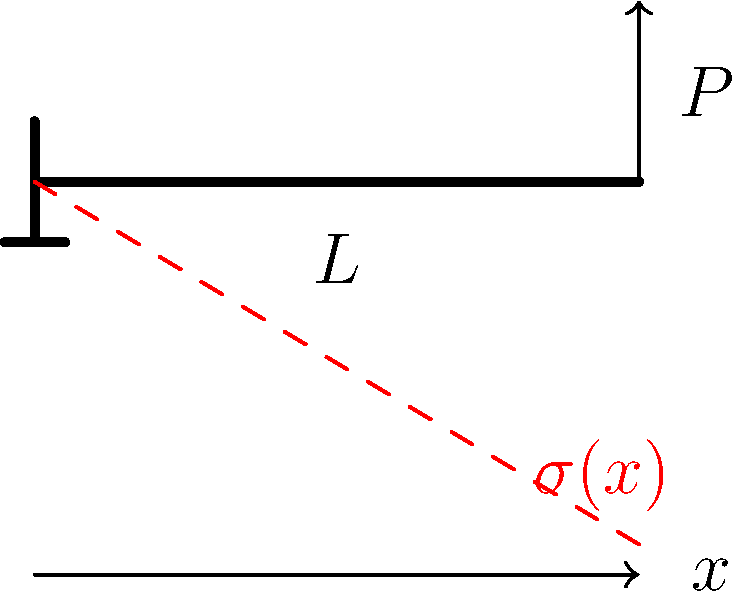Consider a cantilevered beam of length $L$ with a point load $P$ applied at its free end. Given that the stress distribution $\sigma(x)$ along the beam varies linearly, what is the mathematical expression for the bending stress $\sigma(x)$ at any point $x$ along the beam in terms of $P$, $L$, the moment of inertia $I$, and the distance $y$ from the neutral axis? To determine the stress distribution in the cantilevered beam, we'll follow these steps:

1) The bending moment $M(x)$ at any point $x$ along the beam is given by:
   $$M(x) = P(L-x)$$

2) The general equation for bending stress is:
   $$\sigma = \frac{My}{I}$$
   where $M$ is the bending moment, $y$ is the distance from the neutral axis, and $I$ is the moment of inertia.

3) Substituting the expression for $M(x)$ into the bending stress equation:
   $$\sigma(x) = \frac{P(L-x)y}{I}$$

4) This equation shows that the stress varies linearly along the length of the beam (x-direction) and linearly across the cross-section (y-direction).

5) The maximum stress occurs at the fixed end $(x=0)$ and at the outermost fibers of the beam (maximum $y$).

6) The stress is zero at the free end $(x=L)$ and along the neutral axis $(y=0)$.

This linear variation of stress is consistent with the dashed red line shown in the diagram, which represents the stress distribution along the length of the beam.
Answer: $$\sigma(x) = \frac{P(L-x)y}{I}$$ 